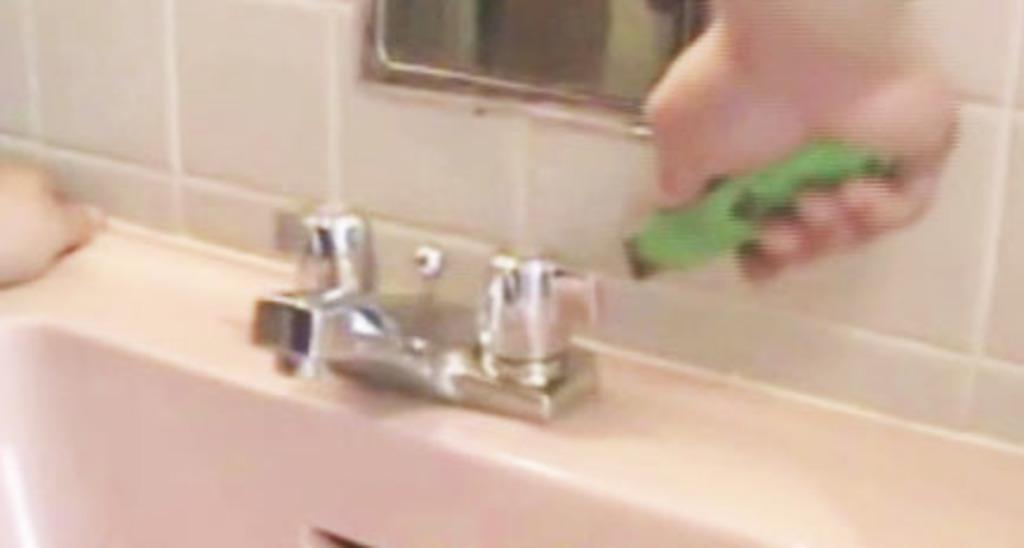Could you give a brief overview of what you see in this image? As we can see in the image there are tiles, human hand, mirror, sink and tap. 